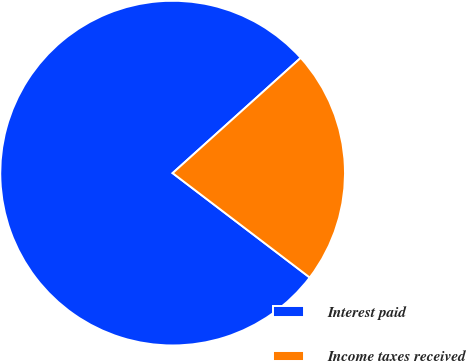Convert chart. <chart><loc_0><loc_0><loc_500><loc_500><pie_chart><fcel>Interest paid<fcel>Income taxes received<nl><fcel>77.98%<fcel>22.02%<nl></chart> 